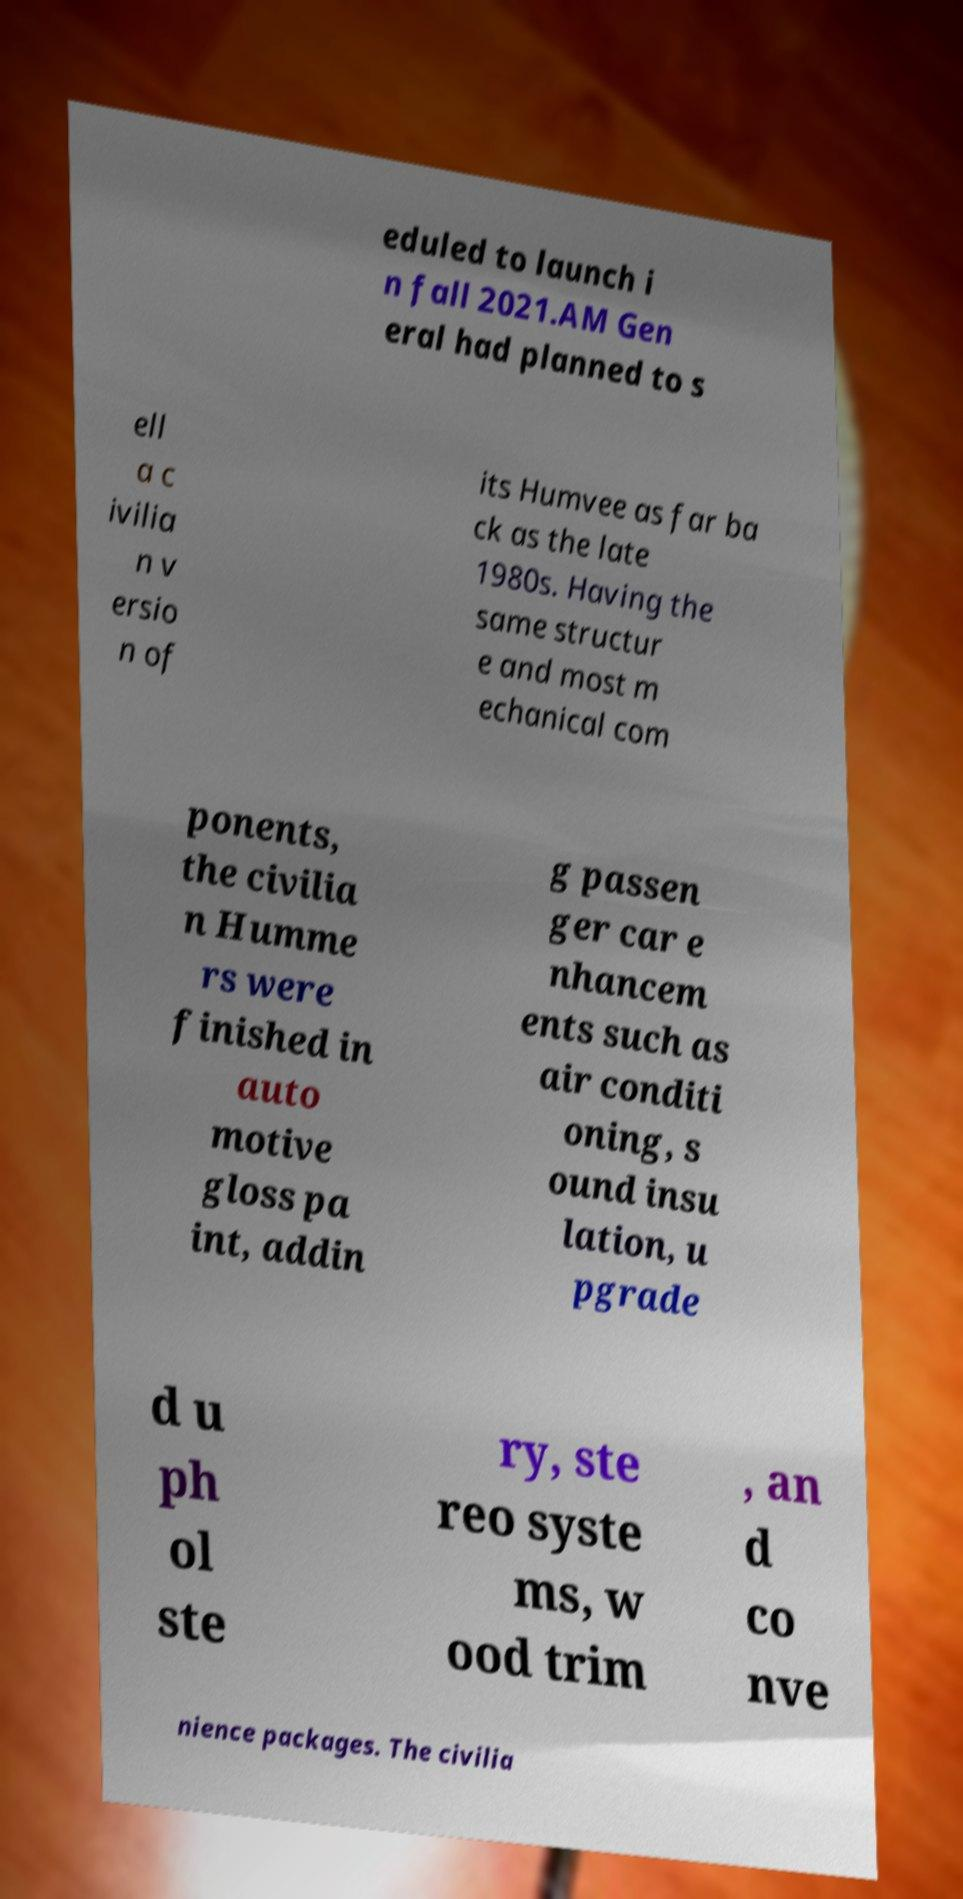Please read and relay the text visible in this image. What does it say? eduled to launch i n fall 2021.AM Gen eral had planned to s ell a c ivilia n v ersio n of its Humvee as far ba ck as the late 1980s. Having the same structur e and most m echanical com ponents, the civilia n Humme rs were finished in auto motive gloss pa int, addin g passen ger car e nhancem ents such as air conditi oning, s ound insu lation, u pgrade d u ph ol ste ry, ste reo syste ms, w ood trim , an d co nve nience packages. The civilia 